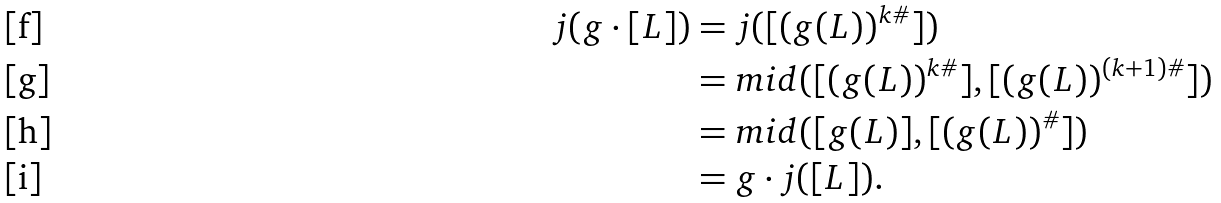<formula> <loc_0><loc_0><loc_500><loc_500>j ( g \cdot [ L ] ) & = j ( [ ( g ( L ) ) ^ { k \# } ] ) \\ & = m i d ( [ ( g ( L ) ) ^ { k \# } ] , [ ( g ( L ) ) ^ { ( k + 1 ) \# } ] ) \\ & = m i d ( [ g ( L ) ] , [ ( g ( L ) ) ^ { \# } ] ) \\ & = g \cdot j ( [ L ] ) .</formula> 